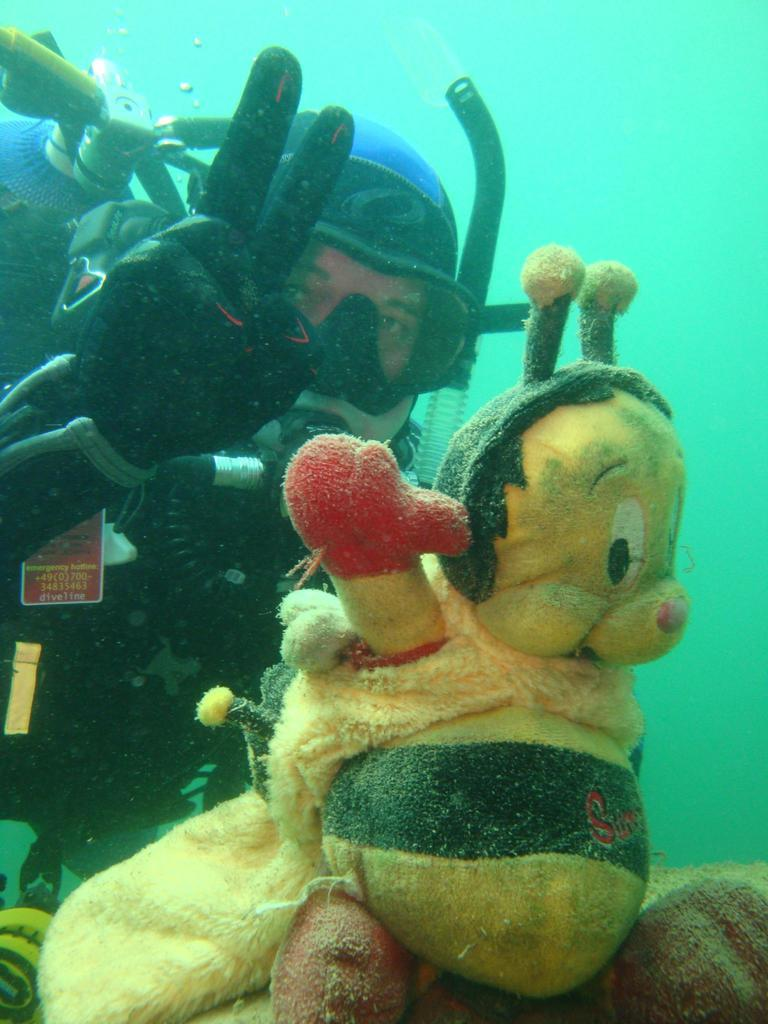What activity is the person in the image engaged in? The person is doing scuba diving. Where is the person located in the image? The person is underwater. What other object can be seen in the image? There is a doll in the image. How is the doll positioned in relation to the person? The doll is in front of the person. What type of ray is covering the person in the image? There is no ray present in the image, and the person is not being covered by any object. Can you tell me how many snails are visible in the image? There are no snails visible in the image. 